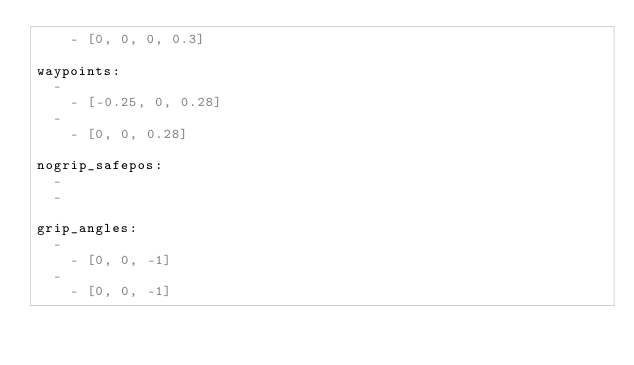Convert code to text. <code><loc_0><loc_0><loc_500><loc_500><_YAML_>    - [0, 0, 0, 0.3]

waypoints:
  -
    - [-0.25, 0, 0.28]
  -
    - [0, 0, 0.28]

nogrip_safepos:
  -
  -

grip_angles:
  -
    - [0, 0, -1]
  -
    - [0, 0, -1]

</code> 